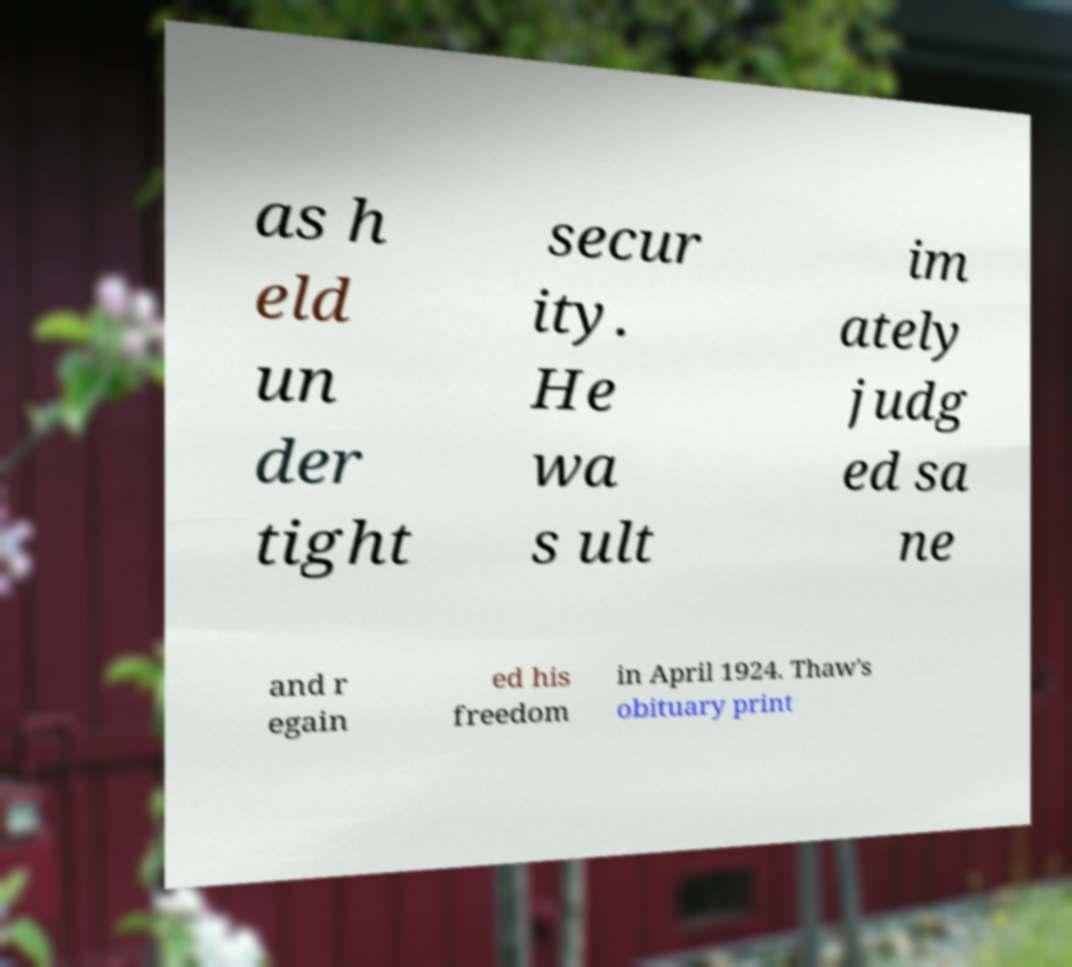Can you accurately transcribe the text from the provided image for me? as h eld un der tight secur ity. He wa s ult im ately judg ed sa ne and r egain ed his freedom in April 1924. Thaw's obituary print 